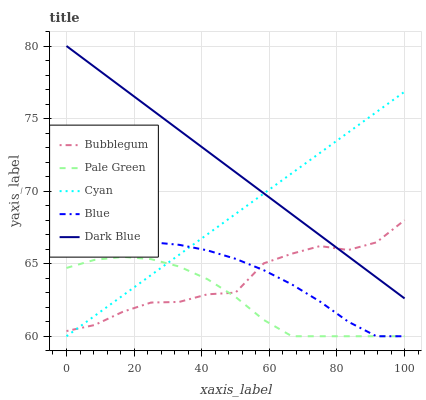Does Pale Green have the minimum area under the curve?
Answer yes or no. Yes. Does Dark Blue have the maximum area under the curve?
Answer yes or no. Yes. Does Cyan have the minimum area under the curve?
Answer yes or no. No. Does Cyan have the maximum area under the curve?
Answer yes or no. No. Is Cyan the smoothest?
Answer yes or no. Yes. Is Bubblegum the roughest?
Answer yes or no. Yes. Is Pale Green the smoothest?
Answer yes or no. No. Is Pale Green the roughest?
Answer yes or no. No. Does Blue have the lowest value?
Answer yes or no. Yes. Does Bubblegum have the lowest value?
Answer yes or no. No. Does Dark Blue have the highest value?
Answer yes or no. Yes. Does Cyan have the highest value?
Answer yes or no. No. Is Pale Green less than Dark Blue?
Answer yes or no. Yes. Is Dark Blue greater than Blue?
Answer yes or no. Yes. Does Cyan intersect Dark Blue?
Answer yes or no. Yes. Is Cyan less than Dark Blue?
Answer yes or no. No. Is Cyan greater than Dark Blue?
Answer yes or no. No. Does Pale Green intersect Dark Blue?
Answer yes or no. No. 